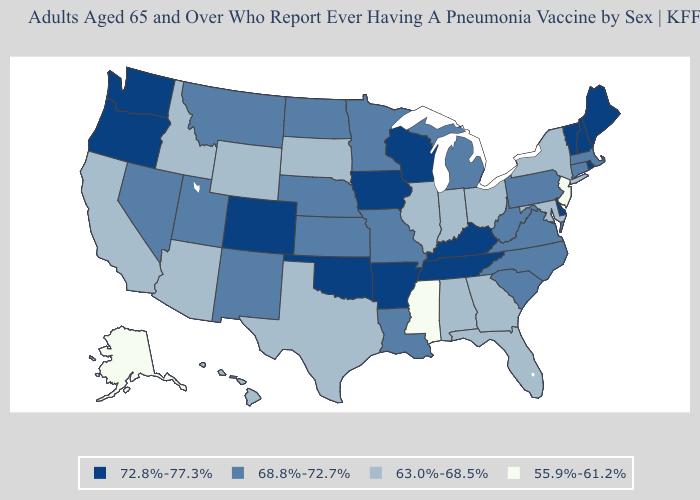What is the lowest value in states that border Texas?
Answer briefly. 68.8%-72.7%. What is the highest value in the MidWest ?
Answer briefly. 72.8%-77.3%. What is the lowest value in states that border Maryland?
Quick response, please. 68.8%-72.7%. Which states hav the highest value in the West?
Concise answer only. Colorado, Oregon, Washington. What is the value of Nevada?
Be succinct. 68.8%-72.7%. Among the states that border North Dakota , does Montana have the lowest value?
Quick response, please. No. Does Massachusetts have the highest value in the Northeast?
Be succinct. No. What is the value of Delaware?
Give a very brief answer. 72.8%-77.3%. Does Washington have the highest value in the USA?
Keep it brief. Yes. Name the states that have a value in the range 72.8%-77.3%?
Answer briefly. Arkansas, Colorado, Delaware, Iowa, Kentucky, Maine, New Hampshire, Oklahoma, Oregon, Rhode Island, Tennessee, Vermont, Washington, Wisconsin. What is the lowest value in the USA?
Be succinct. 55.9%-61.2%. What is the lowest value in the USA?
Keep it brief. 55.9%-61.2%. Name the states that have a value in the range 55.9%-61.2%?
Keep it brief. Alaska, Mississippi, New Jersey. Does Colorado have the highest value in the USA?
Be succinct. Yes. What is the value of Oklahoma?
Answer briefly. 72.8%-77.3%. 